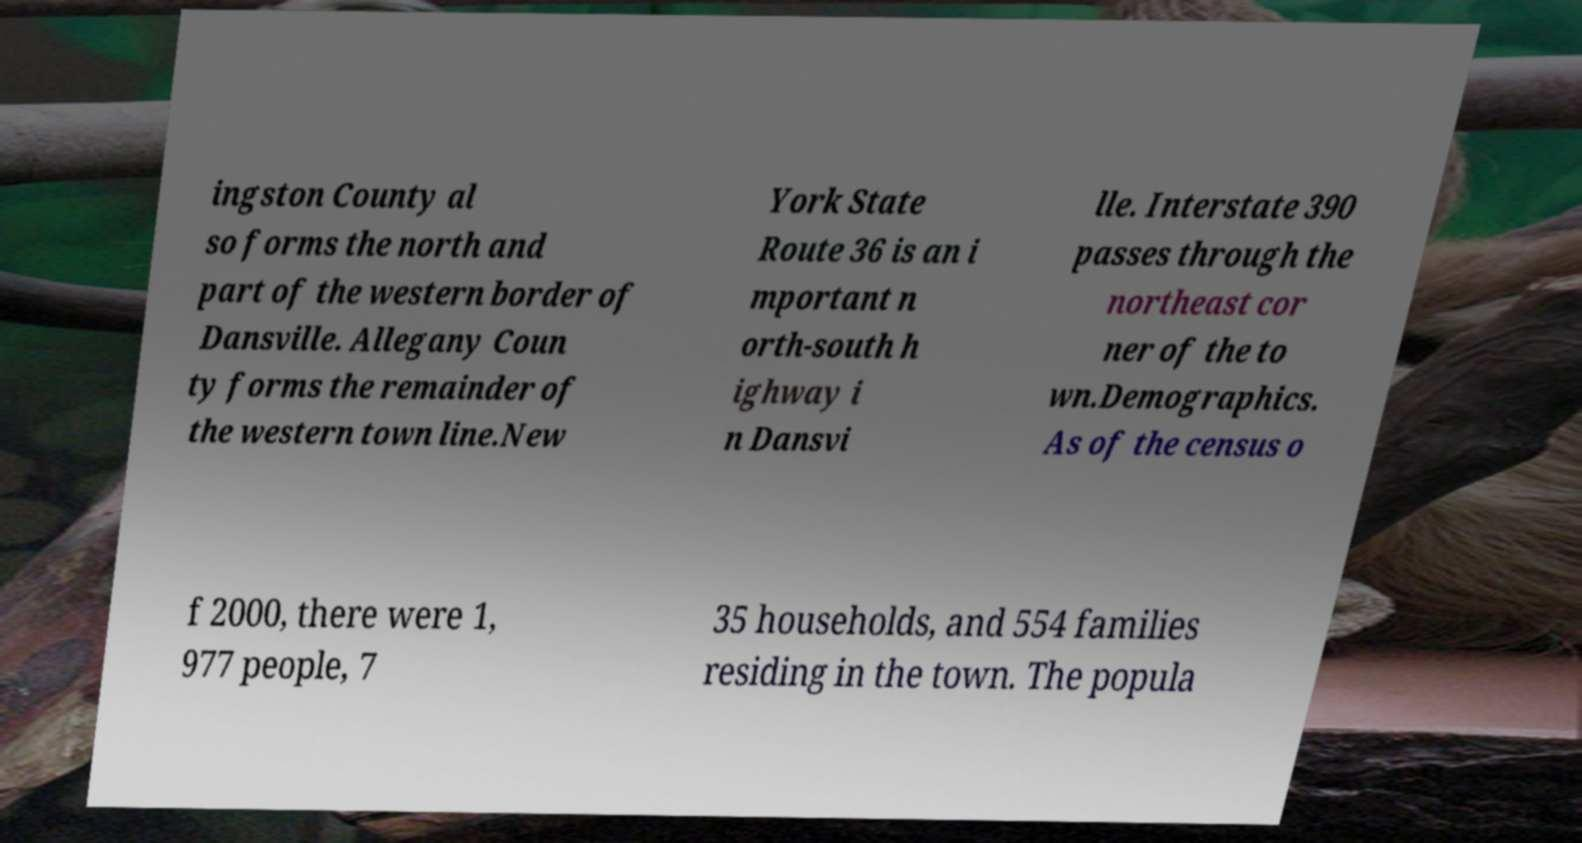Please read and relay the text visible in this image. What does it say? ingston County al so forms the north and part of the western border of Dansville. Allegany Coun ty forms the remainder of the western town line.New York State Route 36 is an i mportant n orth-south h ighway i n Dansvi lle. Interstate 390 passes through the northeast cor ner of the to wn.Demographics. As of the census o f 2000, there were 1, 977 people, 7 35 households, and 554 families residing in the town. The popula 